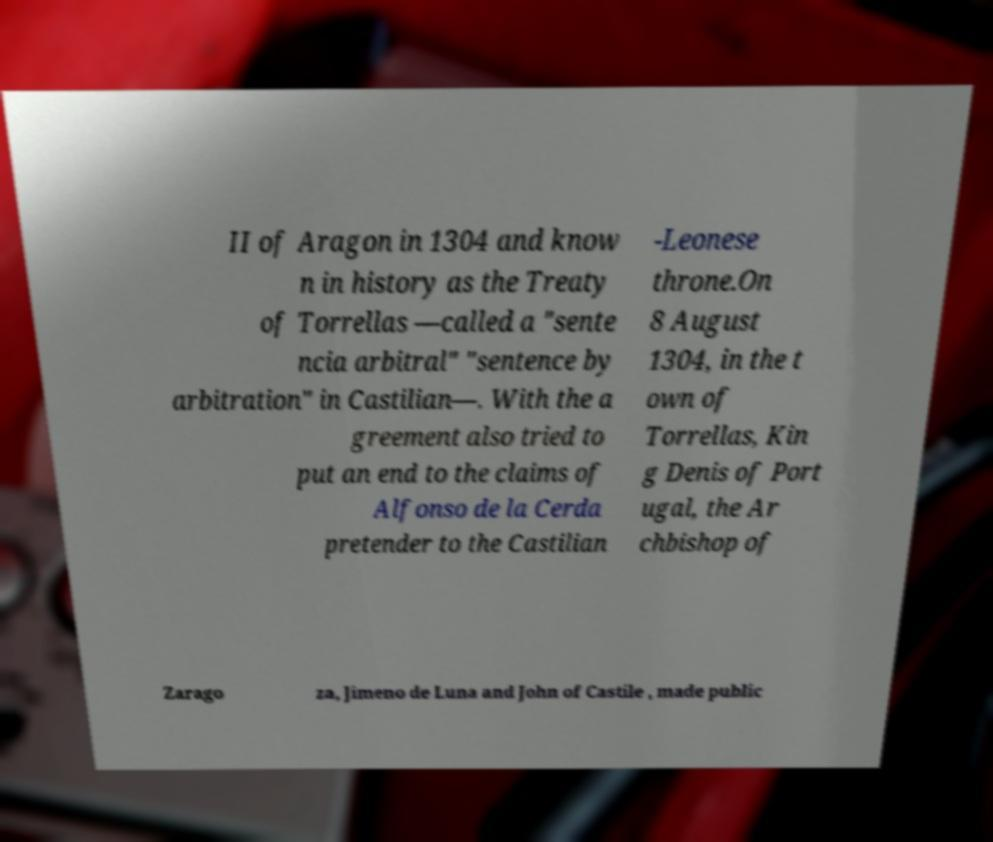Could you extract and type out the text from this image? II of Aragon in 1304 and know n in history as the Treaty of Torrellas —called a "sente ncia arbitral" "sentence by arbitration" in Castilian—. With the a greement also tried to put an end to the claims of Alfonso de la Cerda pretender to the Castilian -Leonese throne.On 8 August 1304, in the t own of Torrellas, Kin g Denis of Port ugal, the Ar chbishop of Zarago za, Jimeno de Luna and John of Castile , made public 